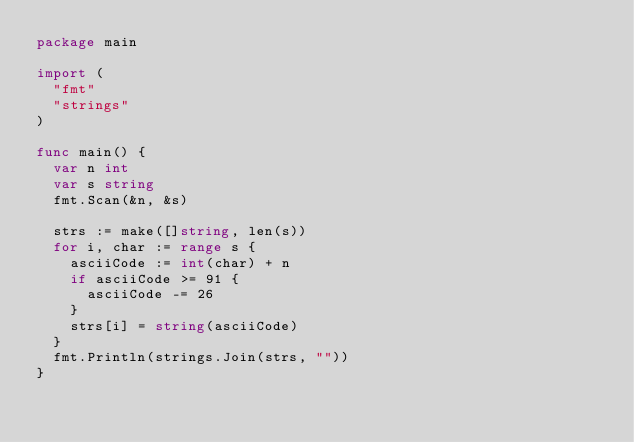Convert code to text. <code><loc_0><loc_0><loc_500><loc_500><_Go_>package main

import (
	"fmt"
	"strings"
)

func main() {
	var n int
	var s string
	fmt.Scan(&n, &s)

	strs := make([]string, len(s))
	for i, char := range s {
		asciiCode := int(char) + n
		if asciiCode >= 91 {
			asciiCode -= 26
		}
		strs[i] = string(asciiCode)
	}
	fmt.Println(strings.Join(strs, ""))
}
</code> 